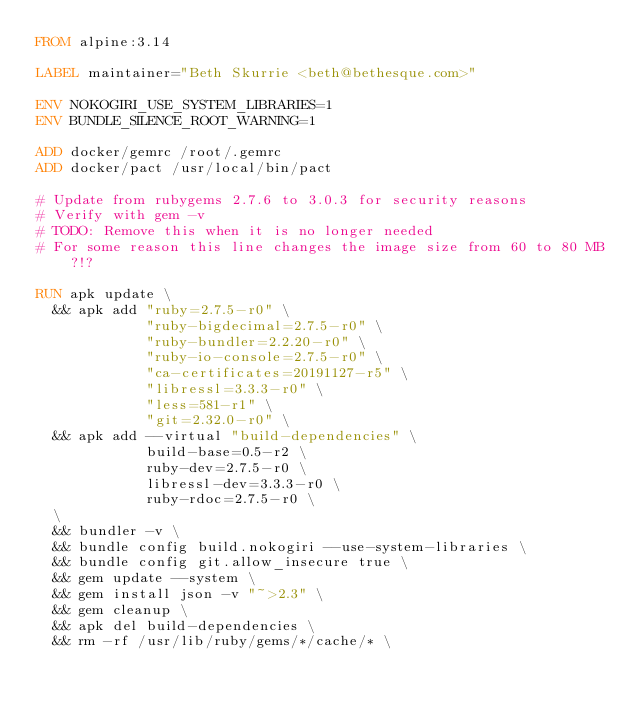<code> <loc_0><loc_0><loc_500><loc_500><_Dockerfile_>FROM alpine:3.14

LABEL maintainer="Beth Skurrie <beth@bethesque.com>"

ENV NOKOGIRI_USE_SYSTEM_LIBRARIES=1
ENV BUNDLE_SILENCE_ROOT_WARNING=1

ADD docker/gemrc /root/.gemrc
ADD docker/pact /usr/local/bin/pact

# Update from rubygems 2.7.6 to 3.0.3 for security reasons
# Verify with gem -v
# TODO: Remove this when it is no longer needed
# For some reason this line changes the image size from 60 to 80 MB?!?

RUN apk update \
  && apk add "ruby=2.7.5-r0" \
             "ruby-bigdecimal=2.7.5-r0" \
             "ruby-bundler=2.2.20-r0" \
             "ruby-io-console=2.7.5-r0" \
             "ca-certificates=20191127-r5" \
             "libressl=3.3.3-r0" \
             "less=581-r1" \
             "git=2.32.0-r0" \
  && apk add --virtual "build-dependencies" \
             build-base=0.5-r2 \
             ruby-dev=2.7.5-r0 \
             libressl-dev=3.3.3-r0 \
             ruby-rdoc=2.7.5-r0 \
  \
  && bundler -v \
  && bundle config build.nokogiri --use-system-libraries \
  && bundle config git.allow_insecure true \
  && gem update --system \
  && gem install json -v "~>2.3" \
  && gem cleanup \
  && apk del build-dependencies \
  && rm -rf /usr/lib/ruby/gems/*/cache/* \</code> 